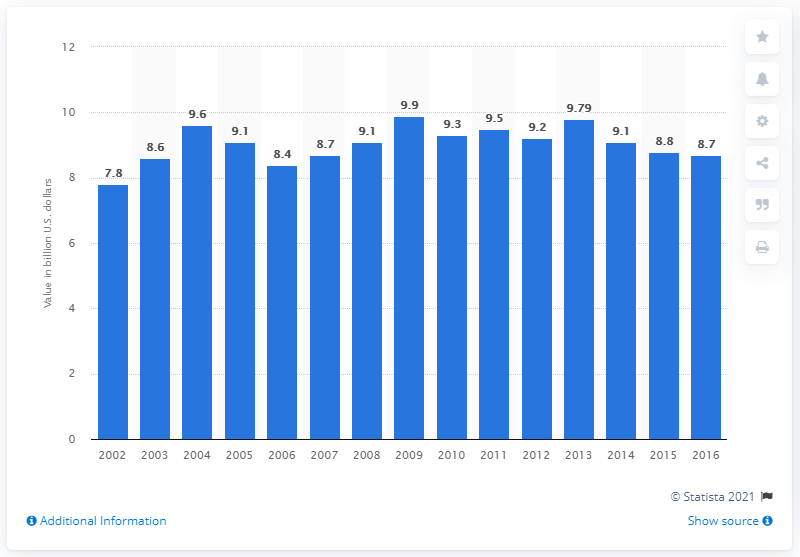Point out several critical features in this image. In 2016, the value of product shipment of breakfast cereals in the United States was $8.7 billion. 